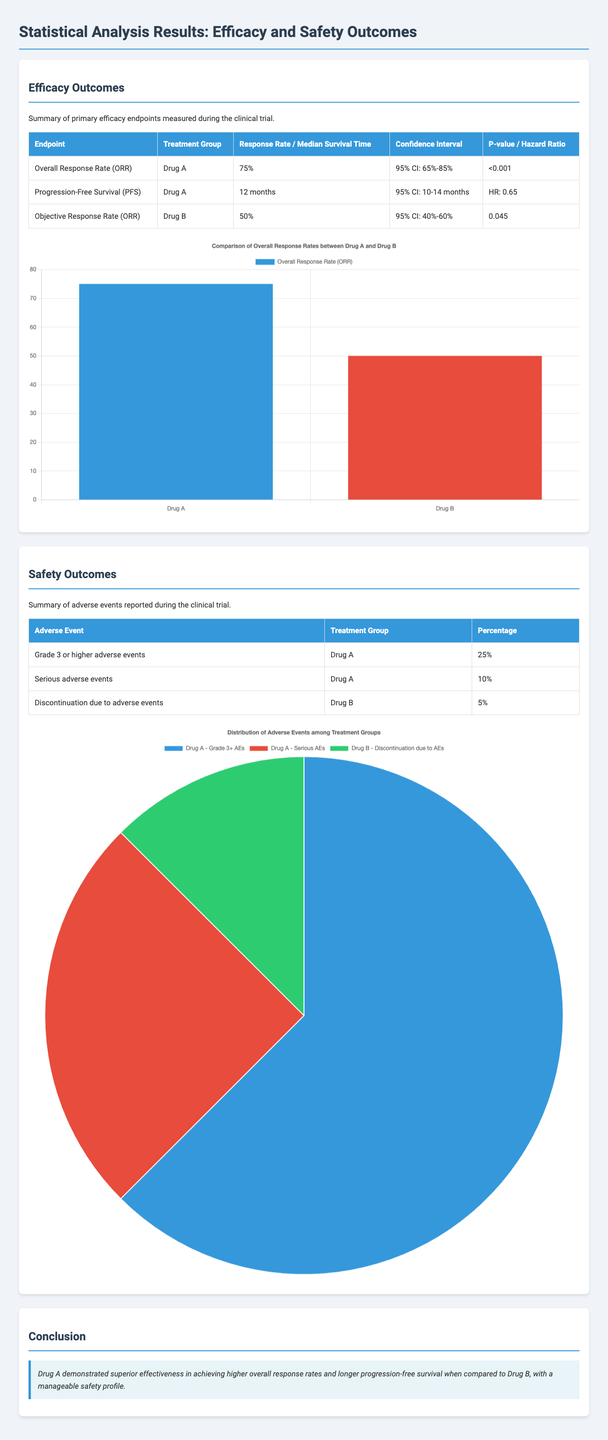What is the Overall Response Rate for Drug A? The Overall Response Rate (ORR) for Drug A is listed in the efficacy table as 75%.
Answer: 75% What is the median survival time for Drug A? The median survival time for Drug A is provided in the efficacy table under Progression-Free Survival as 12 months.
Answer: 12 months What is the P-value for Drug B's Objective Response Rate? The P-value for Drug B's Objective Response Rate is shown in the efficacy table as 0.045.
Answer: 0.045 What percentage of patients experienced Grade 3 or higher adverse events with Drug A? The percentage of patients with Grade 3 or higher adverse events in the safety table for Drug A is 25%.
Answer: 25% Which drug had the higher Overall Response Rate? The information shows that Drug A had a higher Overall Response Rate compared to Drug B, with 75% vs 50%.
Answer: Drug A How many serious adverse events were reported for Drug A? The number of serious adverse events reported for Drug A is listed in the safety table as 10%.
Answer: 10% What is the confidence interval for Drug A's Overall Response Rate? The confidence interval for Drug A's Overall Response Rate is indicated in the efficacy table as 95% CI: 65%-85%.
Answer: 95% CI: 65%-85% What type of chart is used for the safety outcomes? The document utilizes a pie chart for illustrating the distribution of adverse events among treatment groups in the safety section.
Answer: Pie chart What does the conclusion state about Drug A's effectiveness? The conclusion summarizes that Drug A demonstrated superior effectiveness over Drug B with a manageable safety profile.
Answer: Superior effectiveness 